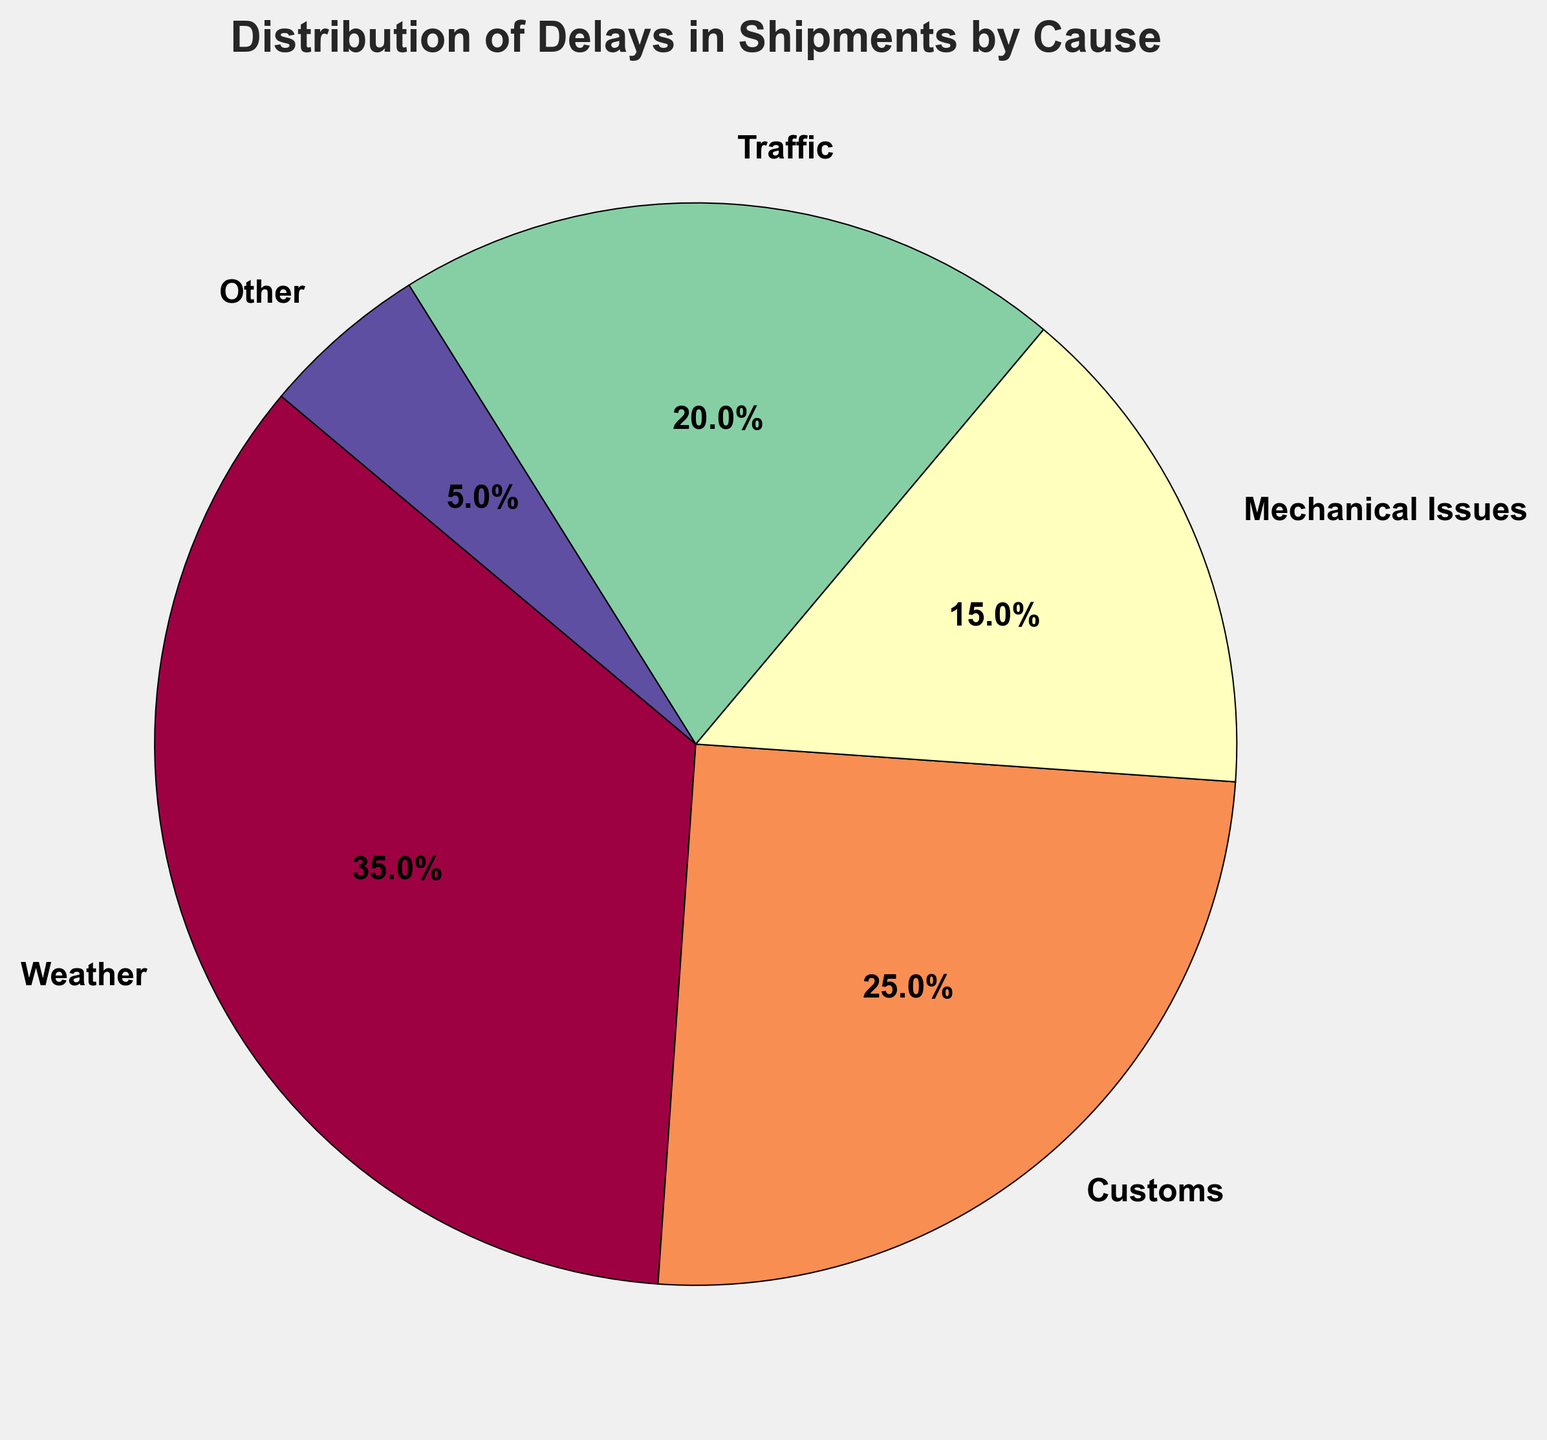What cause has the highest percentage of delays? By looking at the segments of the pie chart, the segment labeled 'Weather' is the largest. The percentage labeled for 'Weather' is also the highest at 35%.
Answer: Weather Are there more delays caused by traffic or mechanical issues? By comparing the sizes of the segments, the 'Traffic' segment is larger than the 'Mechanical Issues' segment. The pie chart labels show 20% for Traffic and 15% for Mechanical Issues.
Answer: Traffic What is the combined percentage of delays caused by customs and traffic? According to the pie chart, Customs delays account for 25% and Traffic delays account for 20%. Summing these percentages gives 25% + 20% = 45%.
Answer: 45% What is the difference in percentage between the cause with the highest delays and the cause with the lowest delays? The highest percentage is from Weather at 35%. The lowest percentage is from 'Other' at 5%. The difference is calculated as 35% - 5% = 30%.
Answer: 30% Which causes combined contribute to more than half of the total delays? By summing the percentages, we get Weather (35%) + Customs (25%) = 60%, which is more than half. Adding any other causes would exceed 100%.
Answer: Weather and Customs Is the total percentage of delays caused by mechanical issues and other issues greater or less than traffic delays? According to the pie chart, Mechanical Issues cause 15% and Other causes 5%, totaling 15% + 5% = 20%, which is equal to Traffic delays which are also 20%.
Answer: Equal What percentage of delays is caused by factors other than weather and customs? The delays caused by Weather and Customs sum to 35% + 25% = 60%. Therefore, delays caused by other factors sum to 100% - 60% = 40%.
Answer: 40% Which cause has the smallest percentage of delays, and what is that percentage? Observing the pie chart, the smallest segment is labeled 'Other' with a percentage of 5%.
Answer: Other, 5% 